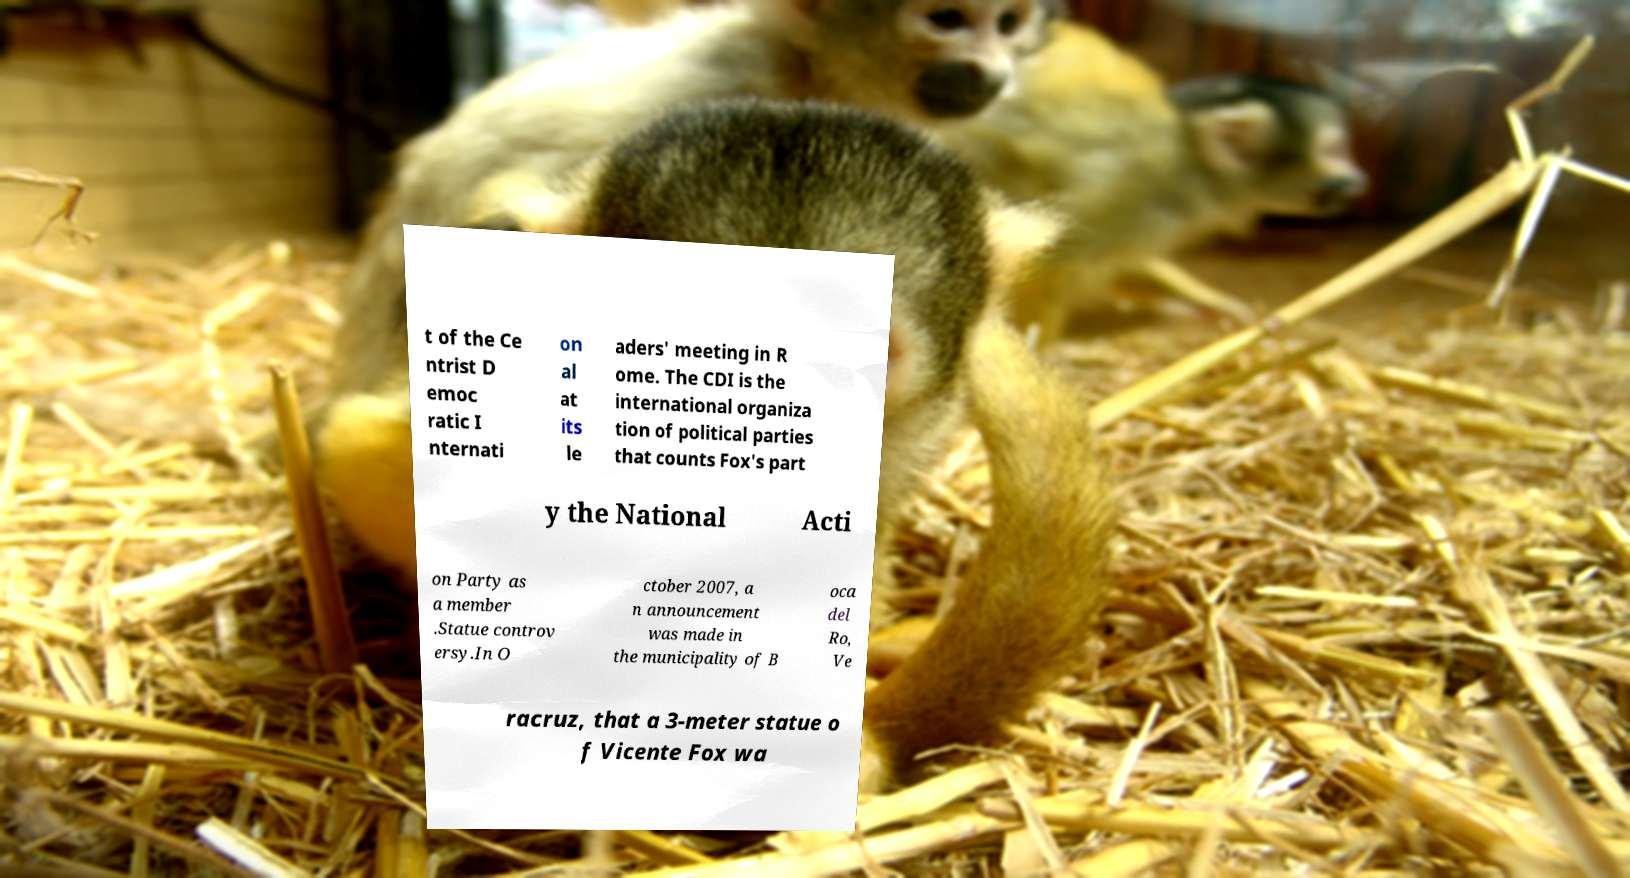There's text embedded in this image that I need extracted. Can you transcribe it verbatim? t of the Ce ntrist D emoc ratic I nternati on al at its le aders' meeting in R ome. The CDI is the international organiza tion of political parties that counts Fox's part y the National Acti on Party as a member .Statue controv ersy.In O ctober 2007, a n announcement was made in the municipality of B oca del Ro, Ve racruz, that a 3-meter statue o f Vicente Fox wa 